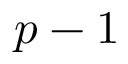<formula> <loc_0><loc_0><loc_500><loc_500>p - 1</formula> 